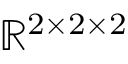Convert formula to latex. <formula><loc_0><loc_0><loc_500><loc_500>\mathbb { R } ^ { 2 \times 2 \times 2 }</formula> 